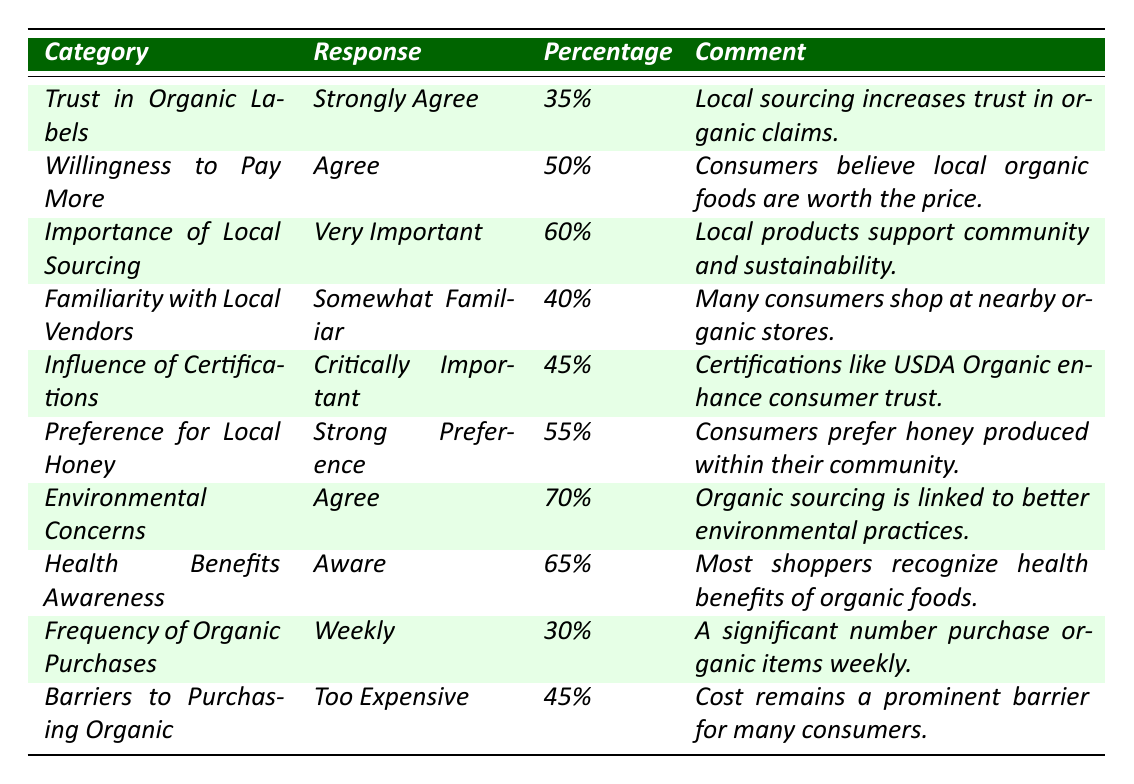What percentage of consumers strongly agree that local sourcing increases trust in organic claims? The table lists the response for "Trust in Organic Labels" with "Strongly Agree," showing a percentage of 35%.
Answer: 35% What category has the highest percentage of agreement regarding environmental concerns? The "Environmental Concerns" category has 70% indicating agreement that organic sourcing is linked to better environmental practices, which is the highest percentage in the table.
Answer: 70% What is the difference in percentage between consumers who feel that local sourcing is very important and those who feel organic foods are too expensive? The importance of local sourcing is rated at 60%, and the barrier to purchasing organic is 45%. The difference is 60% - 45% = 15%.
Answer: 15% Is the majority of consumers aware of the health benefits of organic foods? The "Health Benefits Awareness" category shows 65% of consumers are aware, which is indeed a majority (over 50%).
Answer: Yes What percentage of consumers believe they are somewhat familiar with local vendors? The "Familiarity with Local Vendors" category states that 40% of consumers are somewhat familiar with local vendors.
Answer: 40% If we average the percentages of "Willingness to Pay More" and "Frequency of Organic Purchases," what is the result? "Willingness to Pay More" is 50% and "Frequency of Organic Purchases" is 30%. The average is (50% + 30%) / 2 = 40%.
Answer: 40% What percentage of consumers shows a strong preference for local honey? The "Preference for Local Honey" category indicates a strong preference at 55%.
Answer: 55% How many categories reflect that local sourcing is perceived as very important or important? "Importance of Local Sourcing" shows 60% as very important and "Influence of Certifications" shows 45% as critically important, totaling 2 categories.
Answer: 2 What's the overall impression about the barriers to purchasing organic food? The table indicates a significant barrier with 45% of consumers stating that organic food is too expensive, indicating a common concern among consumers.
Answer: Yes Which category has the lowest percentage, and what is it? "Frequency of Organic Purchases" shows 30%, which is the lowest percentage in the table.
Answer: 30% 